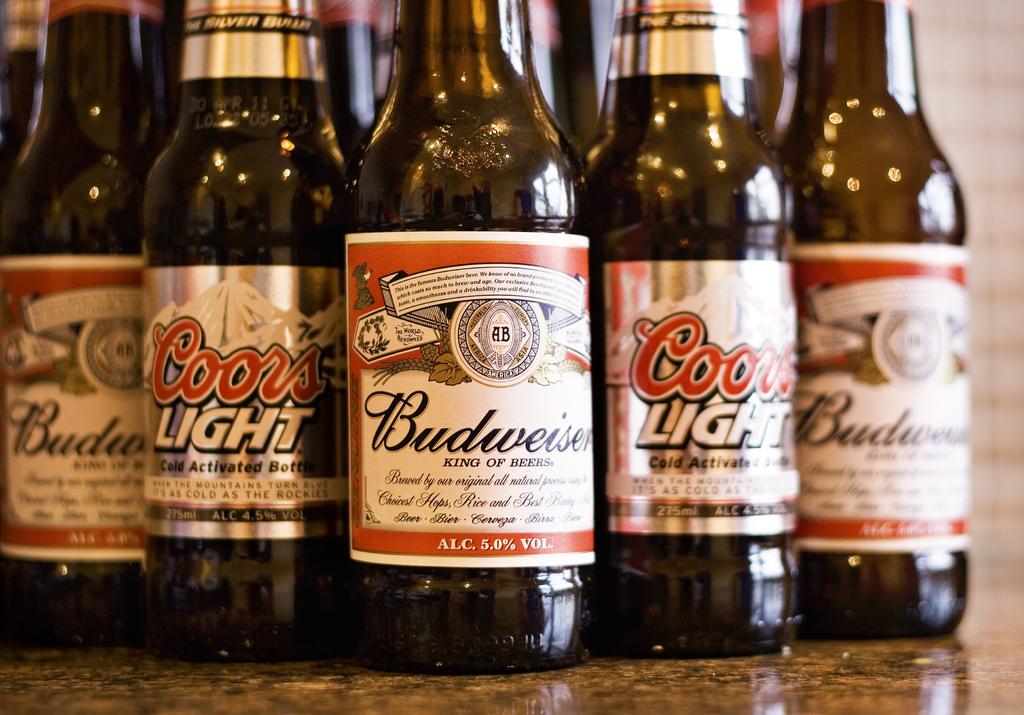What brand is the middle beer?
Your answer should be very brief. Budweiser. 